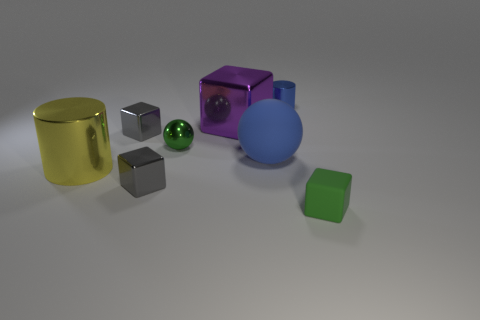Add 2 big yellow metallic blocks. How many objects exist? 10 Subtract all yellow cylinders. How many cylinders are left? 1 Subtract all green rubber cubes. How many cubes are left? 3 Subtract 0 brown balls. How many objects are left? 8 Subtract all cylinders. How many objects are left? 6 Subtract 1 spheres. How many spheres are left? 1 Subtract all yellow cylinders. Subtract all brown balls. How many cylinders are left? 1 Subtract all cyan cylinders. How many red cubes are left? 0 Subtract all large gray spheres. Subtract all small metal balls. How many objects are left? 7 Add 4 tiny green balls. How many tiny green balls are left? 5 